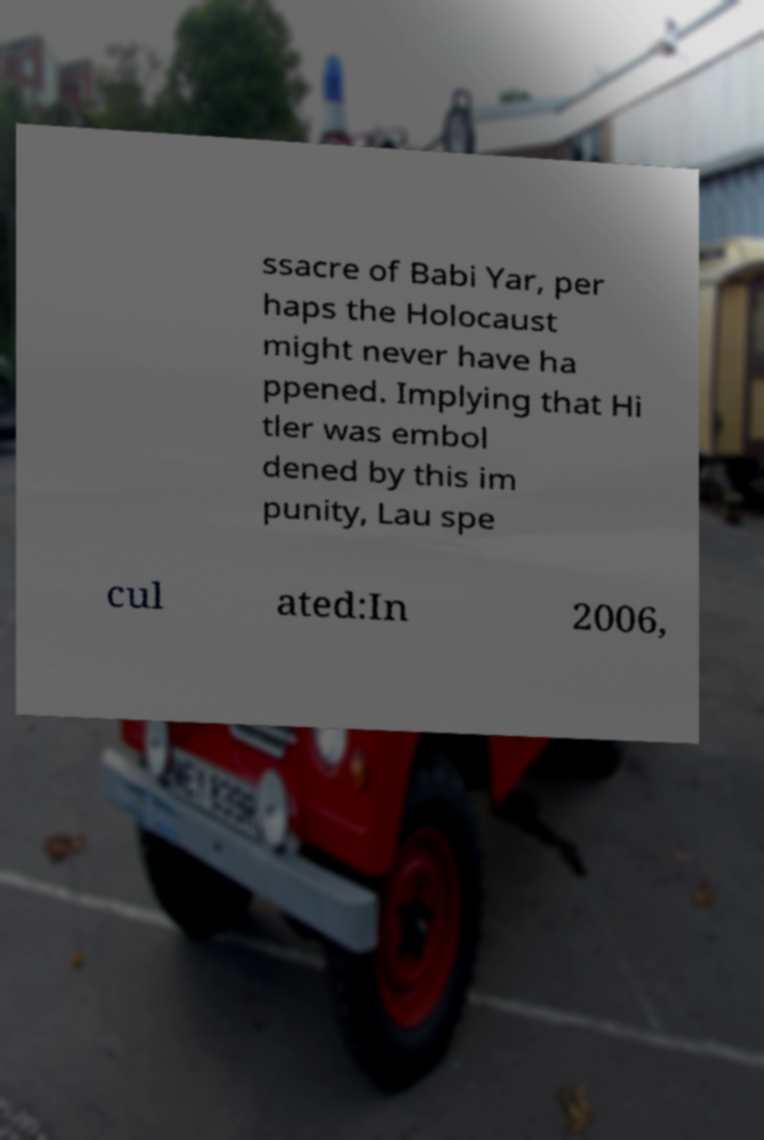Could you extract and type out the text from this image? ssacre of Babi Yar, per haps the Holocaust might never have ha ppened. Implying that Hi tler was embol dened by this im punity, Lau spe cul ated:In 2006, 